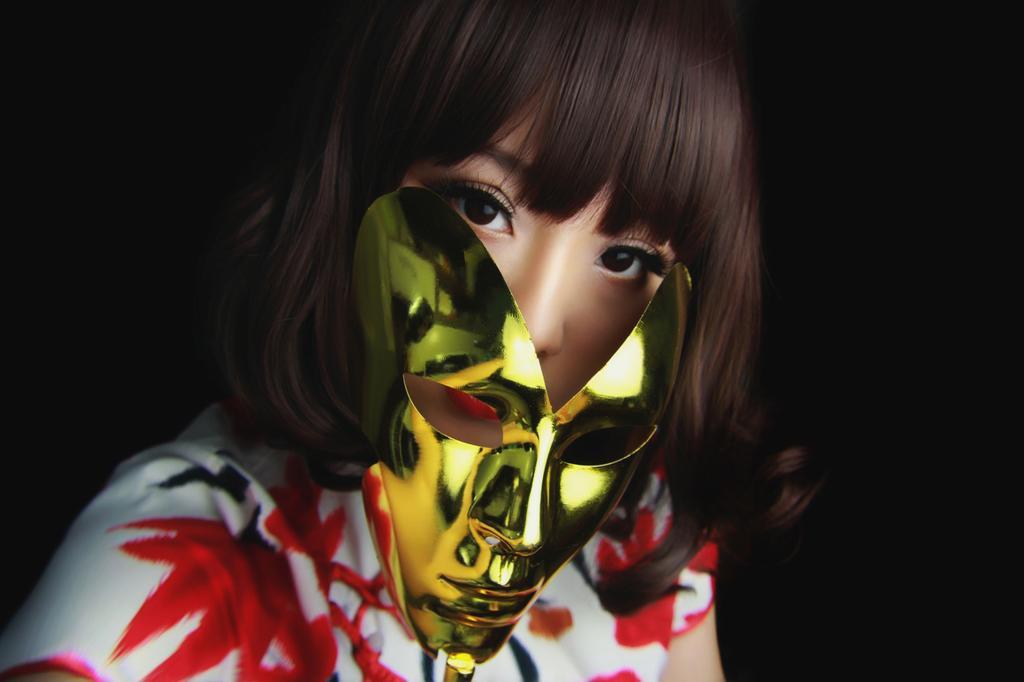Please provide a concise description of this image. Here we can see a person and this is a mask. There is a dark background. 